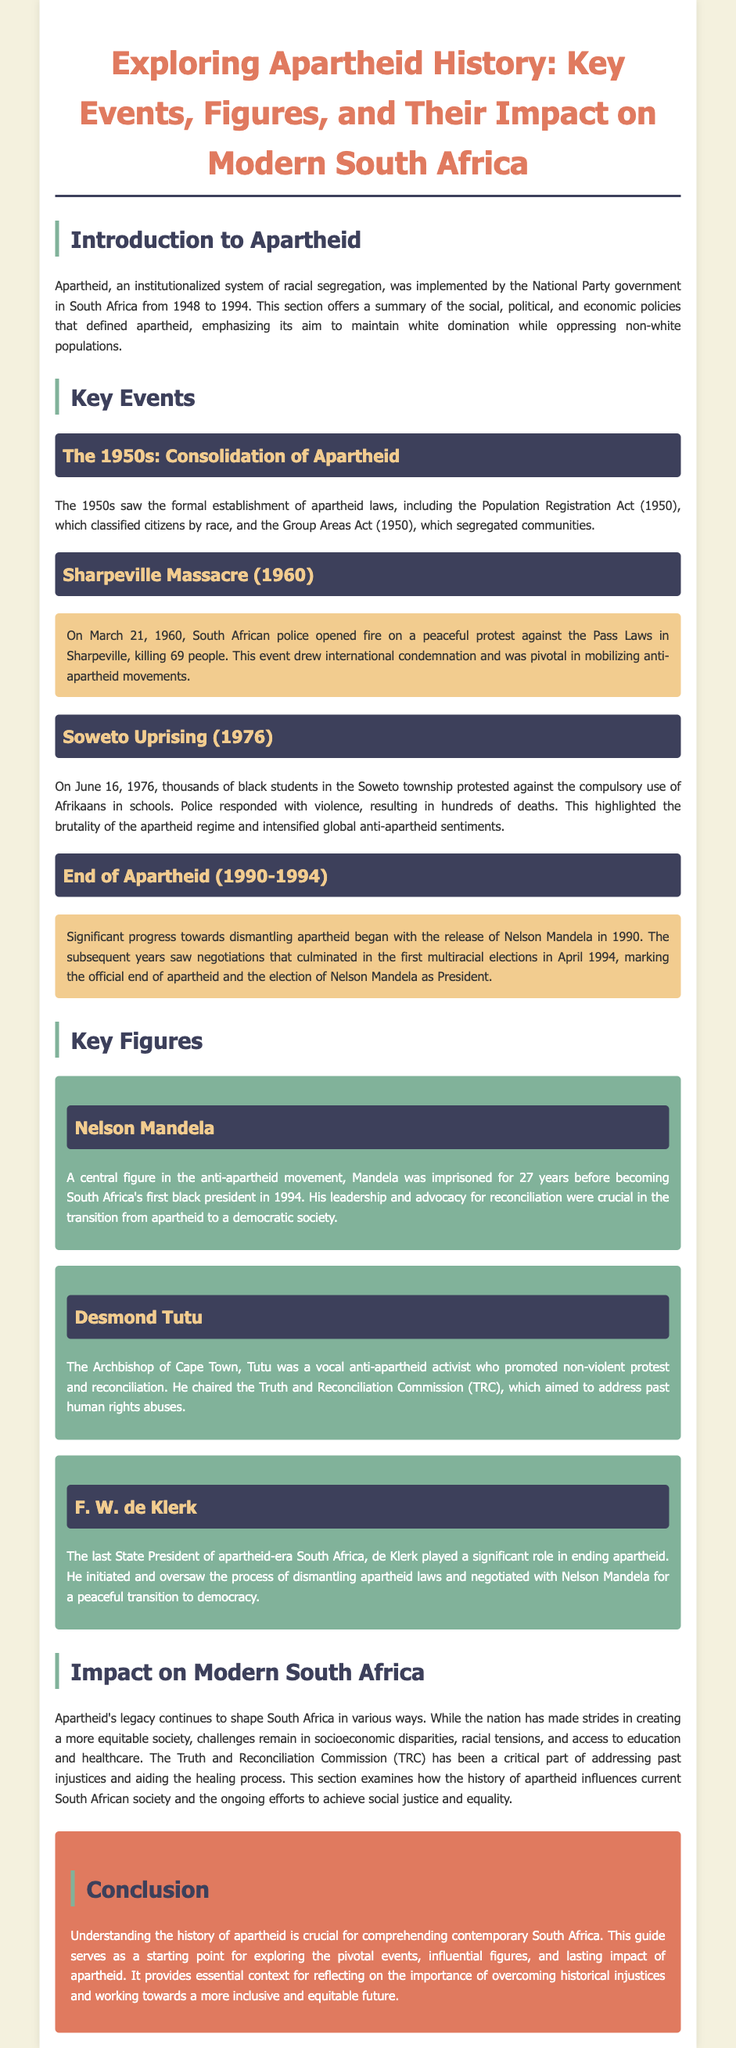What event drew international condemnation in 1960? The Sharpeville Massacre was a pivotal event in 1960 that drew international condemnation due to police violence against a peaceful protest.
Answer: Sharpeville Massacre Who was the first black president of South Africa? Nelson Mandela became the first black president after the end of apartheid in 1994.
Answer: Nelson Mandela What significant act was passed in 1950 to classify citizens by race? The Population Registration Act was implemented in 1950 to classify citizens by race.
Answer: Population Registration Act When did the Soweto Uprising occur? The Soweto Uprising occurred on June 16, 1976, marking a significant protest against apartheid policies.
Answer: June 16, 1976 Who chaired the Truth and Reconciliation Commission? Desmond Tutu chaired the Truth and Reconciliation Commission, promoting reconciliation and addressing past injustices.
Answer: Desmond Tutu What year did Nelson Mandela get released from prison? Nelson Mandela was released from prison in 1990, leading to progress towards ending apartheid.
Answer: 1990 What was the primary aim of apartheid policies? The primary aim of apartheid policies was to maintain white domination while oppressing non-white populations.
Answer: Maintain white domination What years mark the implementation of apartheid in South Africa? Apartheid was implemented by the National Party government from 1948 to 1994.
Answer: 1948 to 1994 What impact did apartheid's legacy have on modern South Africa? Apartheid's legacy continues to shape South Africa, affecting socioeconomic disparities and racial tensions.
Answer: Socioeconomic disparities and racial tensions 